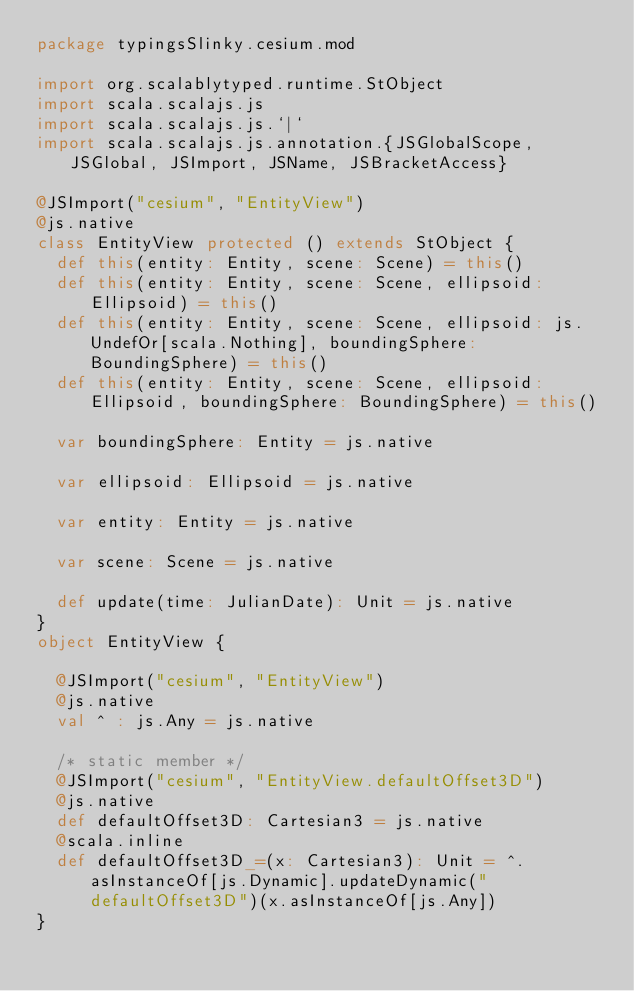<code> <loc_0><loc_0><loc_500><loc_500><_Scala_>package typingsSlinky.cesium.mod

import org.scalablytyped.runtime.StObject
import scala.scalajs.js
import scala.scalajs.js.`|`
import scala.scalajs.js.annotation.{JSGlobalScope, JSGlobal, JSImport, JSName, JSBracketAccess}

@JSImport("cesium", "EntityView")
@js.native
class EntityView protected () extends StObject {
  def this(entity: Entity, scene: Scene) = this()
  def this(entity: Entity, scene: Scene, ellipsoid: Ellipsoid) = this()
  def this(entity: Entity, scene: Scene, ellipsoid: js.UndefOr[scala.Nothing], boundingSphere: BoundingSphere) = this()
  def this(entity: Entity, scene: Scene, ellipsoid: Ellipsoid, boundingSphere: BoundingSphere) = this()
  
  var boundingSphere: Entity = js.native
  
  var ellipsoid: Ellipsoid = js.native
  
  var entity: Entity = js.native
  
  var scene: Scene = js.native
  
  def update(time: JulianDate): Unit = js.native
}
object EntityView {
  
  @JSImport("cesium", "EntityView")
  @js.native
  val ^ : js.Any = js.native
  
  /* static member */
  @JSImport("cesium", "EntityView.defaultOffset3D")
  @js.native
  def defaultOffset3D: Cartesian3 = js.native
  @scala.inline
  def defaultOffset3D_=(x: Cartesian3): Unit = ^.asInstanceOf[js.Dynamic].updateDynamic("defaultOffset3D")(x.asInstanceOf[js.Any])
}
</code> 